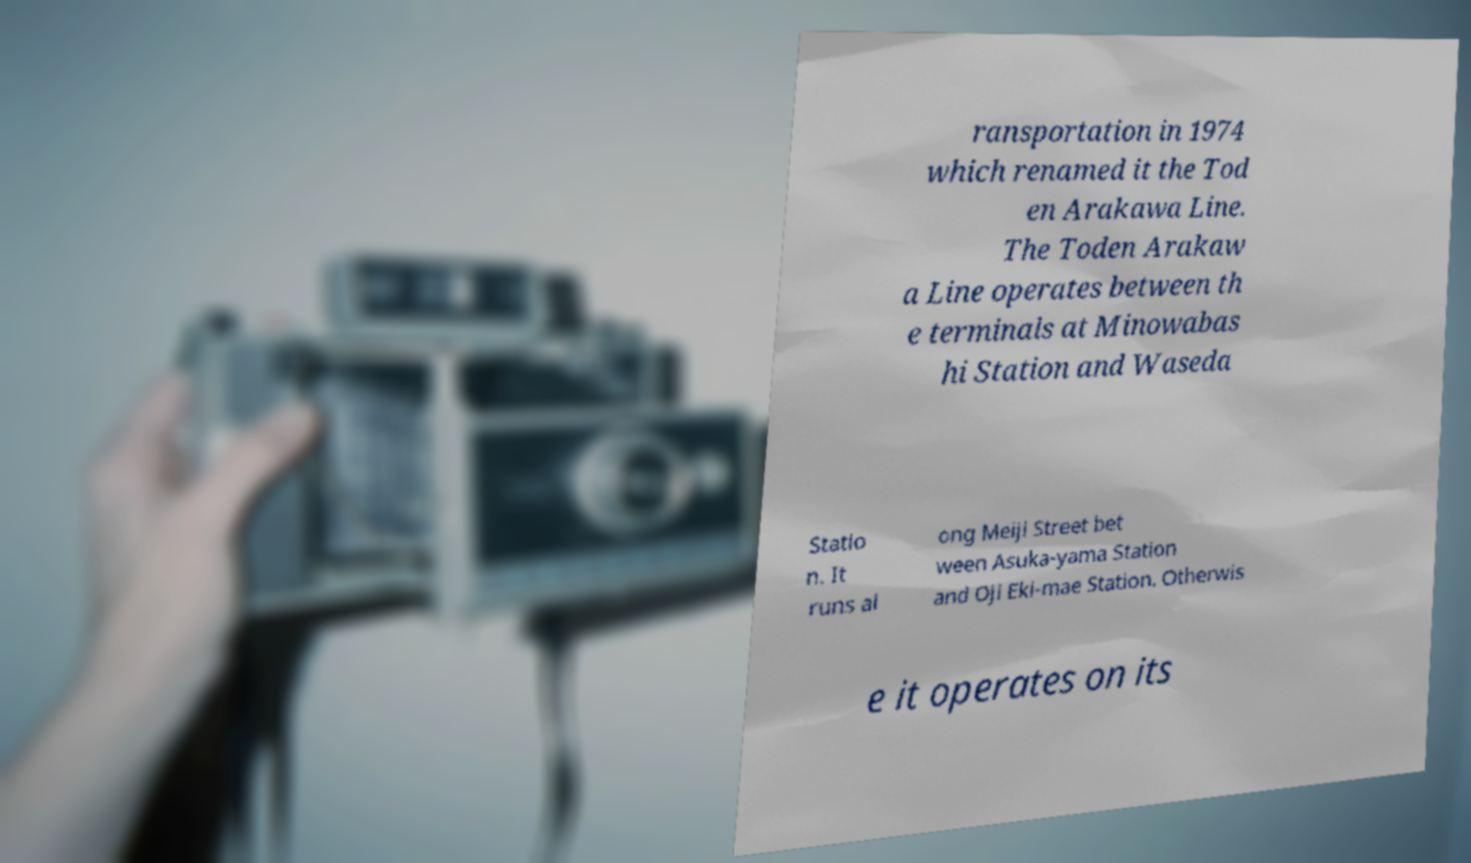Could you assist in decoding the text presented in this image and type it out clearly? ransportation in 1974 which renamed it the Tod en Arakawa Line. The Toden Arakaw a Line operates between th e terminals at Minowabas hi Station and Waseda Statio n. It runs al ong Meiji Street bet ween Asuka-yama Station and Oji Eki-mae Station. Otherwis e it operates on its 